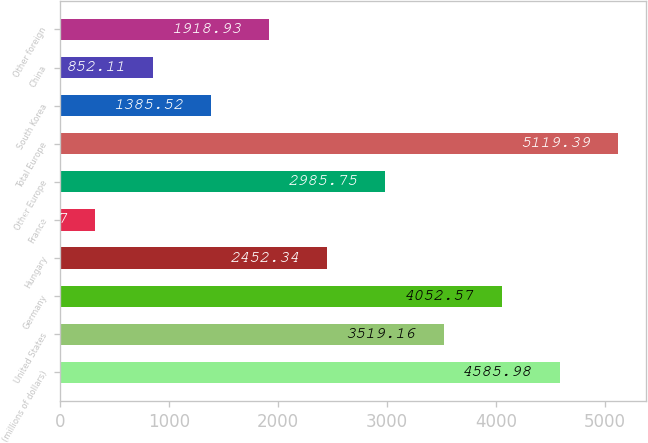Convert chart. <chart><loc_0><loc_0><loc_500><loc_500><bar_chart><fcel>(millions of dollars)<fcel>United States<fcel>Germany<fcel>Hungary<fcel>France<fcel>Other Europe<fcel>Total Europe<fcel>South Korea<fcel>China<fcel>Other foreign<nl><fcel>4585.98<fcel>3519.16<fcel>4052.57<fcel>2452.34<fcel>318.7<fcel>2985.75<fcel>5119.39<fcel>1385.52<fcel>852.11<fcel>1918.93<nl></chart> 